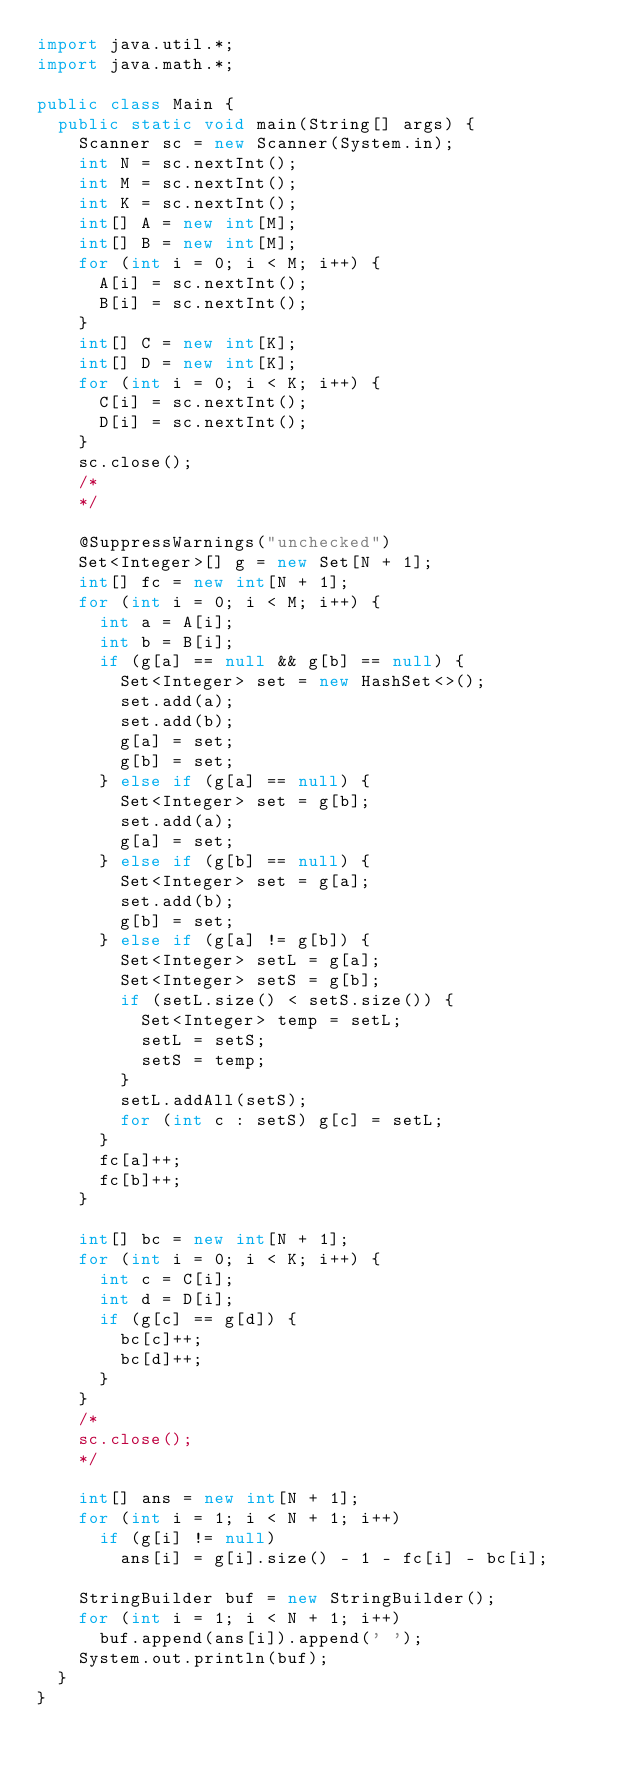Convert code to text. <code><loc_0><loc_0><loc_500><loc_500><_Java_>import java.util.*;
import java.math.*;

public class Main {
  public static void main(String[] args) {
    Scanner sc = new Scanner(System.in);
    int N = sc.nextInt();
    int M = sc.nextInt();
    int K = sc.nextInt();
    int[] A = new int[M];
    int[] B = new int[M];
    for (int i = 0; i < M; i++) {
      A[i] = sc.nextInt();
      B[i] = sc.nextInt();
    }
    int[] C = new int[K];
    int[] D = new int[K];
    for (int i = 0; i < K; i++) {
      C[i] = sc.nextInt();
      D[i] = sc.nextInt();
    }
    sc.close();
    /*
    */

    @SuppressWarnings("unchecked")
    Set<Integer>[] g = new Set[N + 1];
    int[] fc = new int[N + 1];
    for (int i = 0; i < M; i++) {
      int a = A[i];
      int b = B[i];
      if (g[a] == null && g[b] == null) {
        Set<Integer> set = new HashSet<>();
        set.add(a);
        set.add(b);
        g[a] = set;
        g[b] = set;
      } else if (g[a] == null) {
        Set<Integer> set = g[b];
        set.add(a);
        g[a] = set;
      } else if (g[b] == null) {
        Set<Integer> set = g[a];
        set.add(b);
        g[b] = set;
      } else if (g[a] != g[b]) {
        Set<Integer> setL = g[a];
        Set<Integer> setS = g[b];
        if (setL.size() < setS.size()) {
          Set<Integer> temp = setL;
          setL = setS;
          setS = temp;
        }
        setL.addAll(setS);
        for (int c : setS) g[c] = setL;
      }
      fc[a]++;
      fc[b]++;
    }

    int[] bc = new int[N + 1];
    for (int i = 0; i < K; i++) {
      int c = C[i];
      int d = D[i];
      if (g[c] == g[d]) {
        bc[c]++;
        bc[d]++;
      }
    }
    /*
    sc.close();
    */

    int[] ans = new int[N + 1];
    for (int i = 1; i < N + 1; i++)
      if (g[i] != null)
        ans[i] = g[i].size() - 1 - fc[i] - bc[i];

    StringBuilder buf = new StringBuilder();
    for (int i = 1; i < N + 1; i++)
      buf.append(ans[i]).append(' ');
    System.out.println(buf);
  }
}</code> 